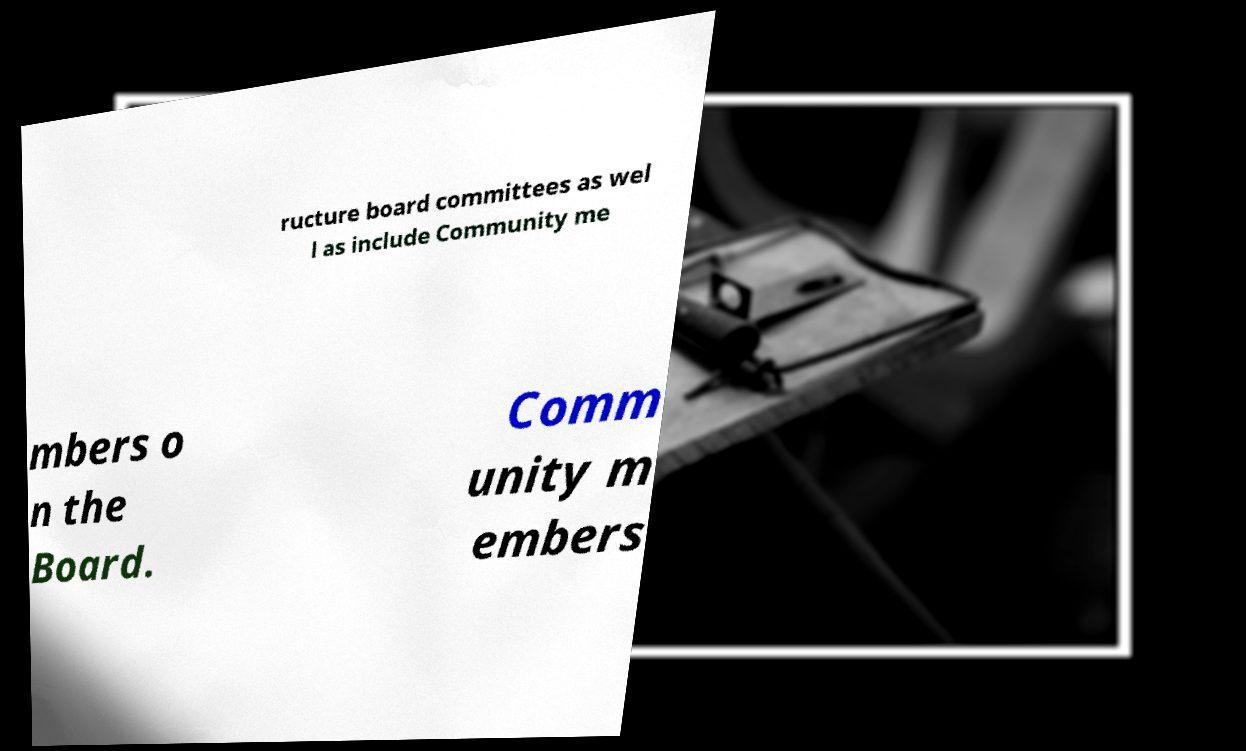Please identify and transcribe the text found in this image. ructure board committees as wel l as include Community me mbers o n the Board. Comm unity m embers 